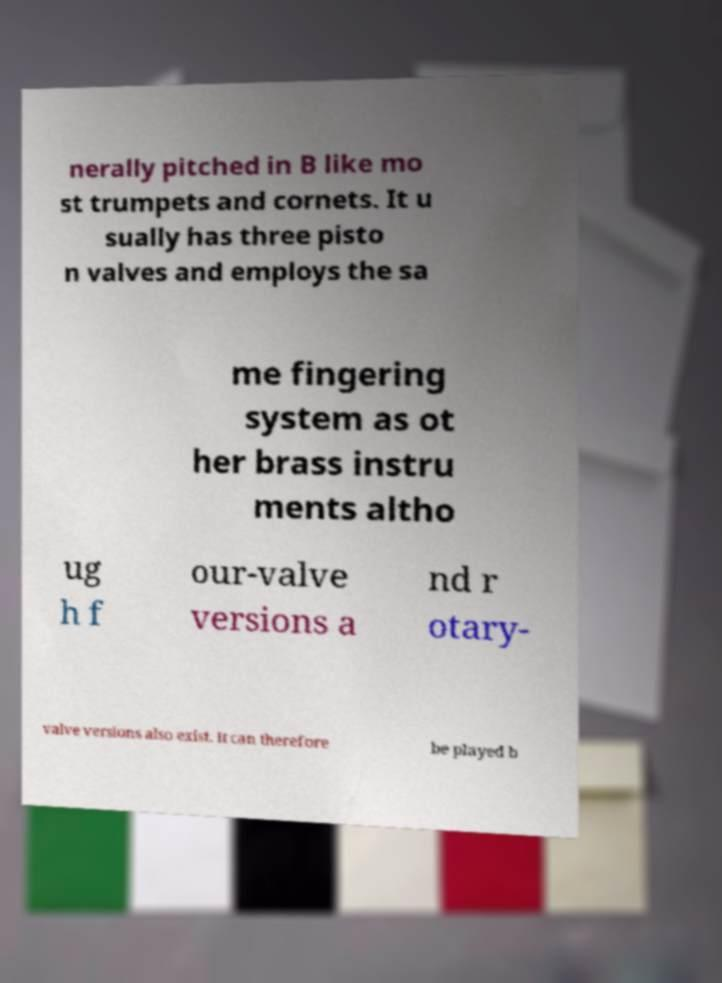Could you assist in decoding the text presented in this image and type it out clearly? nerally pitched in B like mo st trumpets and cornets. It u sually has three pisto n valves and employs the sa me fingering system as ot her brass instru ments altho ug h f our-valve versions a nd r otary- valve versions also exist. It can therefore be played b 